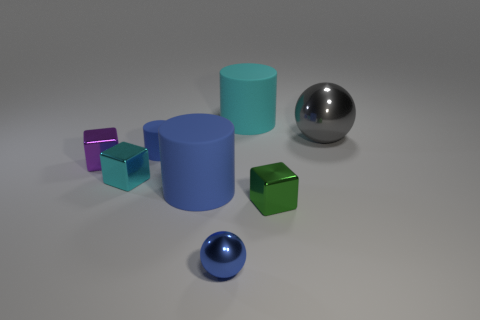How many blue matte cylinders have the same size as the blue sphere?
Make the answer very short. 1. How many green objects are big metal things or tiny cubes?
Provide a short and direct response. 1. There is a tiny shiny thing that is in front of the metal block on the right side of the tiny metal sphere; what shape is it?
Keep it short and to the point. Sphere. What is the shape of the blue matte thing that is the same size as the green shiny cube?
Offer a terse response. Cylinder. Is there a ball of the same color as the small cylinder?
Your response must be concise. Yes. Are there an equal number of tiny green things that are behind the purple object and large blue rubber cylinders that are behind the big gray metal thing?
Offer a very short reply. Yes. Does the small purple thing have the same shape as the cyan thing on the left side of the small shiny ball?
Provide a succinct answer. Yes. How many other things are the same material as the large sphere?
Provide a short and direct response. 4. There is a tiny metallic ball; are there any large things left of it?
Your answer should be very brief. Yes. There is a purple metal object; is its size the same as the blue shiny object that is in front of the small matte cylinder?
Provide a succinct answer. Yes. 